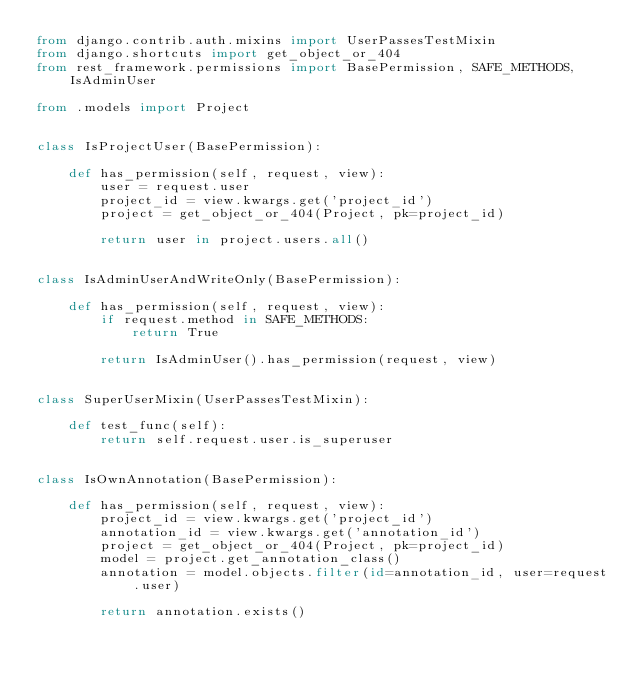Convert code to text. <code><loc_0><loc_0><loc_500><loc_500><_Python_>from django.contrib.auth.mixins import UserPassesTestMixin
from django.shortcuts import get_object_or_404
from rest_framework.permissions import BasePermission, SAFE_METHODS, IsAdminUser

from .models import Project


class IsProjectUser(BasePermission):

    def has_permission(self, request, view):
        user = request.user
        project_id = view.kwargs.get('project_id')
        project = get_object_or_404(Project, pk=project_id)

        return user in project.users.all()


class IsAdminUserAndWriteOnly(BasePermission):

    def has_permission(self, request, view):
        if request.method in SAFE_METHODS:
            return True

        return IsAdminUser().has_permission(request, view)


class SuperUserMixin(UserPassesTestMixin):

    def test_func(self):
        return self.request.user.is_superuser


class IsOwnAnnotation(BasePermission):

    def has_permission(self, request, view):
        project_id = view.kwargs.get('project_id')
        annotation_id = view.kwargs.get('annotation_id')
        project = get_object_or_404(Project, pk=project_id)
        model = project.get_annotation_class()
        annotation = model.objects.filter(id=annotation_id, user=request.user)

        return annotation.exists()
</code> 